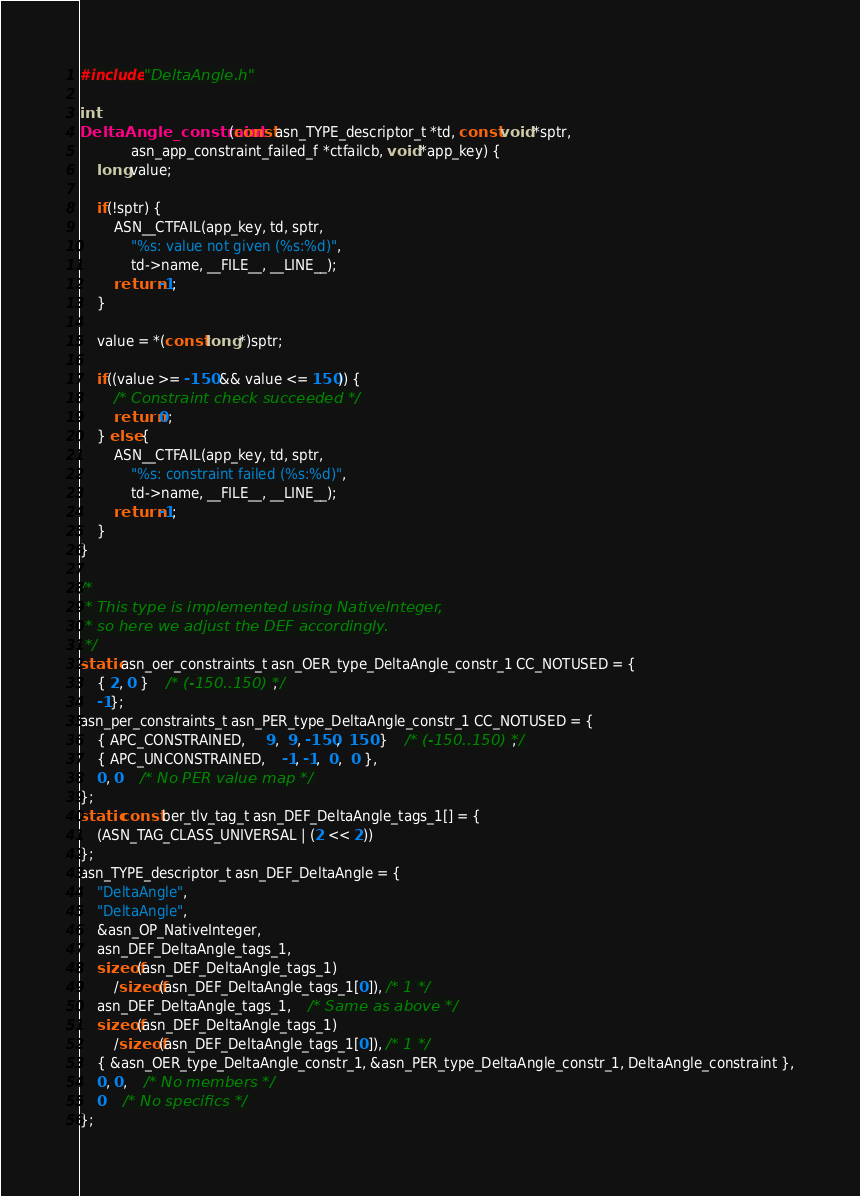<code> <loc_0><loc_0><loc_500><loc_500><_C_>
#include "DeltaAngle.h"

int
DeltaAngle_constraint(const asn_TYPE_descriptor_t *td, const void *sptr,
			asn_app_constraint_failed_f *ctfailcb, void *app_key) {
	long value;
	
	if(!sptr) {
		ASN__CTFAIL(app_key, td, sptr,
			"%s: value not given (%s:%d)",
			td->name, __FILE__, __LINE__);
		return -1;
	}
	
	value = *(const long *)sptr;
	
	if((value >= -150 && value <= 150)) {
		/* Constraint check succeeded */
		return 0;
	} else {
		ASN__CTFAIL(app_key, td, sptr,
			"%s: constraint failed (%s:%d)",
			td->name, __FILE__, __LINE__);
		return -1;
	}
}

/*
 * This type is implemented using NativeInteger,
 * so here we adjust the DEF accordingly.
 */
static asn_oer_constraints_t asn_OER_type_DeltaAngle_constr_1 CC_NOTUSED = {
	{ 2, 0 }	/* (-150..150) */,
	-1};
asn_per_constraints_t asn_PER_type_DeltaAngle_constr_1 CC_NOTUSED = {
	{ APC_CONSTRAINED,	 9,  9, -150,  150 }	/* (-150..150) */,
	{ APC_UNCONSTRAINED,	-1, -1,  0,  0 },
	0, 0	/* No PER value map */
};
static const ber_tlv_tag_t asn_DEF_DeltaAngle_tags_1[] = {
	(ASN_TAG_CLASS_UNIVERSAL | (2 << 2))
};
asn_TYPE_descriptor_t asn_DEF_DeltaAngle = {
	"DeltaAngle",
	"DeltaAngle",
	&asn_OP_NativeInteger,
	asn_DEF_DeltaAngle_tags_1,
	sizeof(asn_DEF_DeltaAngle_tags_1)
		/sizeof(asn_DEF_DeltaAngle_tags_1[0]), /* 1 */
	asn_DEF_DeltaAngle_tags_1,	/* Same as above */
	sizeof(asn_DEF_DeltaAngle_tags_1)
		/sizeof(asn_DEF_DeltaAngle_tags_1[0]), /* 1 */
	{ &asn_OER_type_DeltaAngle_constr_1, &asn_PER_type_DeltaAngle_constr_1, DeltaAngle_constraint },
	0, 0,	/* No members */
	0	/* No specifics */
};

</code> 